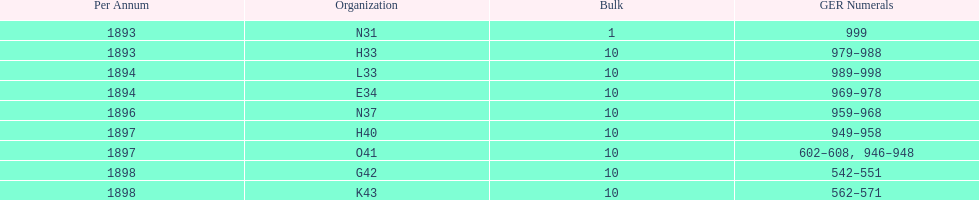Which order was the next order after l33? E34. 